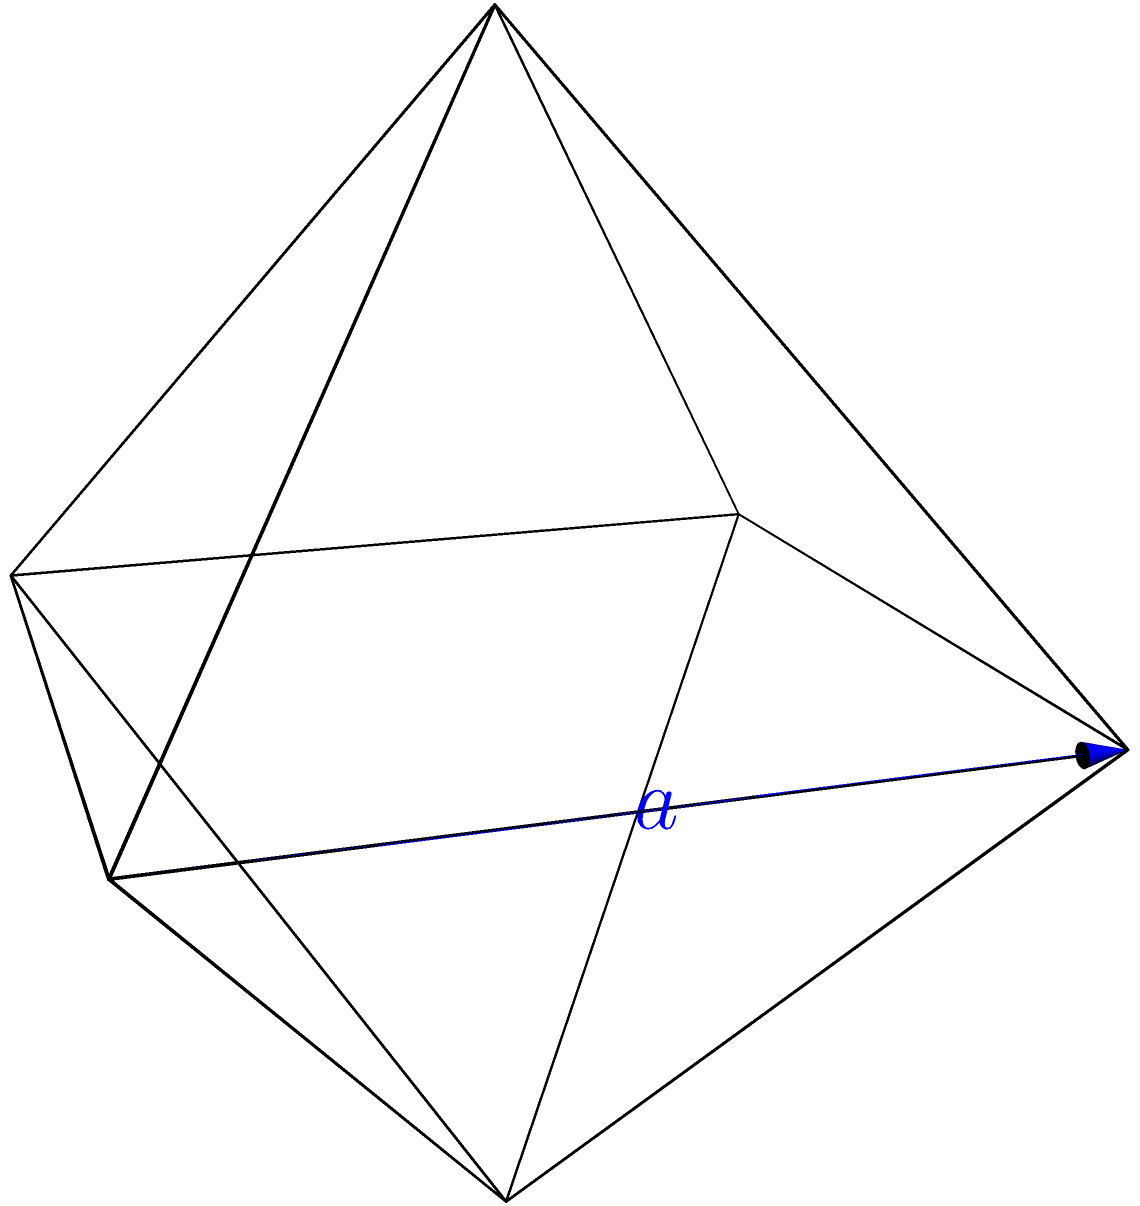In the context of analyzing the structural patterns of morphemes in agglutinative languages, consider a regular octahedron as a metaphor for the interconnected nature of affixes. If each edge of this octahedron represents a unique morpheme with a length of $a$ units, determine the total surface area of the octahedron. How might this relate to the concept of morphological complexity in highly inflected languages? Let's approach this step-by-step:

1) First, recall that a regular octahedron consists of 8 equilateral triangular faces.

2) To find the surface area, we need to calculate the area of one triangular face and multiply it by 8.

3) The area of an equilateral triangle with side length $a$ is given by the formula:

   $$A_{\text{triangle}} = \frac{\sqrt{3}}{4}a^2$$

4) Now, we multiply this by 8 to get the total surface area:

   $$A_{\text{total}} = 8 \cdot \frac{\sqrt{3}}{4}a^2 = 2\sqrt{3}a^2$$

5) Therefore, the surface area of a regular octahedron with edge length $a$ is $2\sqrt{3}a^2$.

Relating this to linguistics:
- Each face could represent a different grammatical category (e.g., tense, aspect, mood, person, number).
- The interconnectedness of the faces mirrors how morphemes in agglutinative languages combine to create complex word forms.
- The surface area growing quadratically with edge length could be seen as analogous to how morphological complexity increases rapidly as more affixes are added in highly inflected languages.
Answer: $2\sqrt{3}a^2$ 